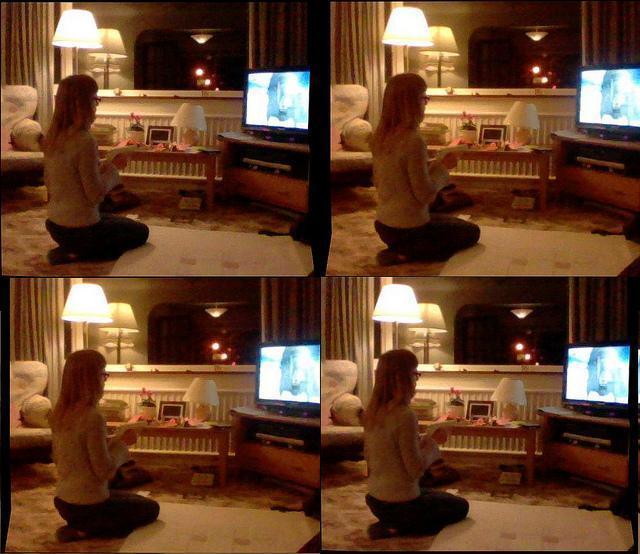How many people are there?
Give a very brief answer. 4. How many tvs are visible?
Give a very brief answer. 4. How many chairs can you see?
Give a very brief answer. 4. 